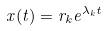Convert formula to latex. <formula><loc_0><loc_0><loc_500><loc_500>x ( t ) = r _ { k } e ^ { \lambda _ { k } t }</formula> 